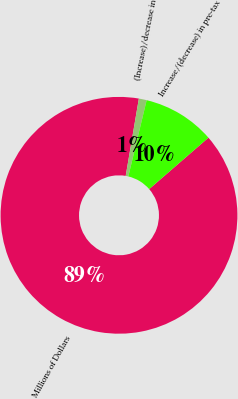<chart> <loc_0><loc_0><loc_500><loc_500><pie_chart><fcel>Millions of Dollars<fcel>(Increase)/decrease in<fcel>Increase/(decrease) in pre-tax<nl><fcel>89.07%<fcel>1.07%<fcel>9.87%<nl></chart> 